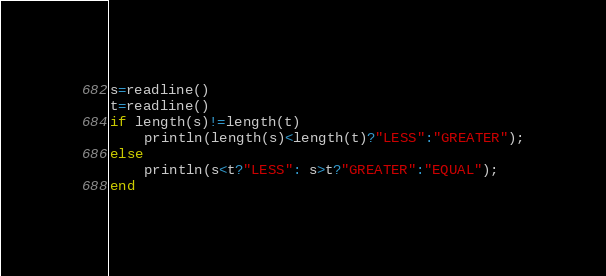Convert code to text. <code><loc_0><loc_0><loc_500><loc_500><_Julia_>s=readline()
t=readline()
if length(s)!=length(t)
	println(length(s)<length(t)?"LESS":"GREATER");
else
	println(s<t?"LESS": s>t?"GREATER":"EQUAL");
end
</code> 